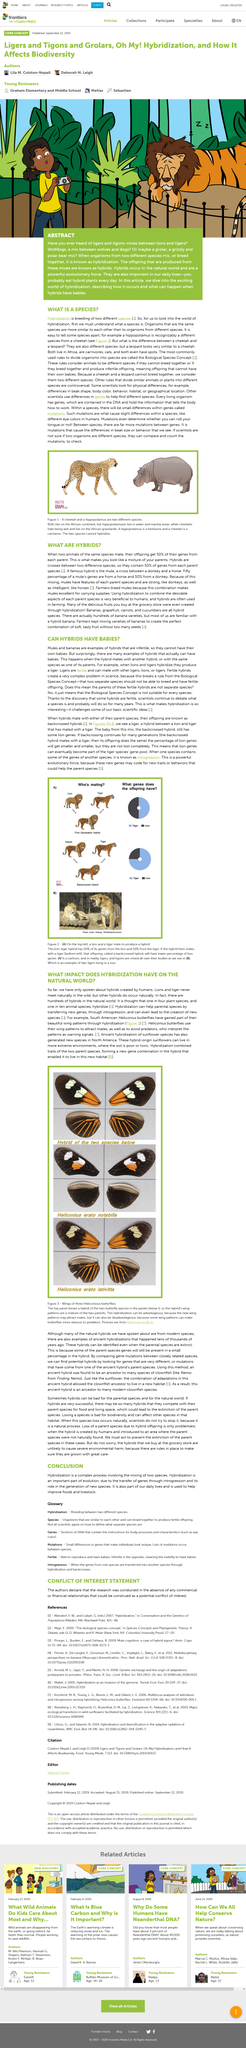Highlight a few significant elements in this photo. Genes are located within the DNA molecule. Introgression is the transfer of genetic material from one species to another through hybridization or backcrossing, resulting in the integration of genes from the introgressed species into the recipient population. Heliconius erato lativitta is a butterfly. A liger is a hybrid or offspring of a tiger and lion. Animals like lions and tigers, who have never been known to meet in the wild, will never come into contact with each other under any circumstances. 